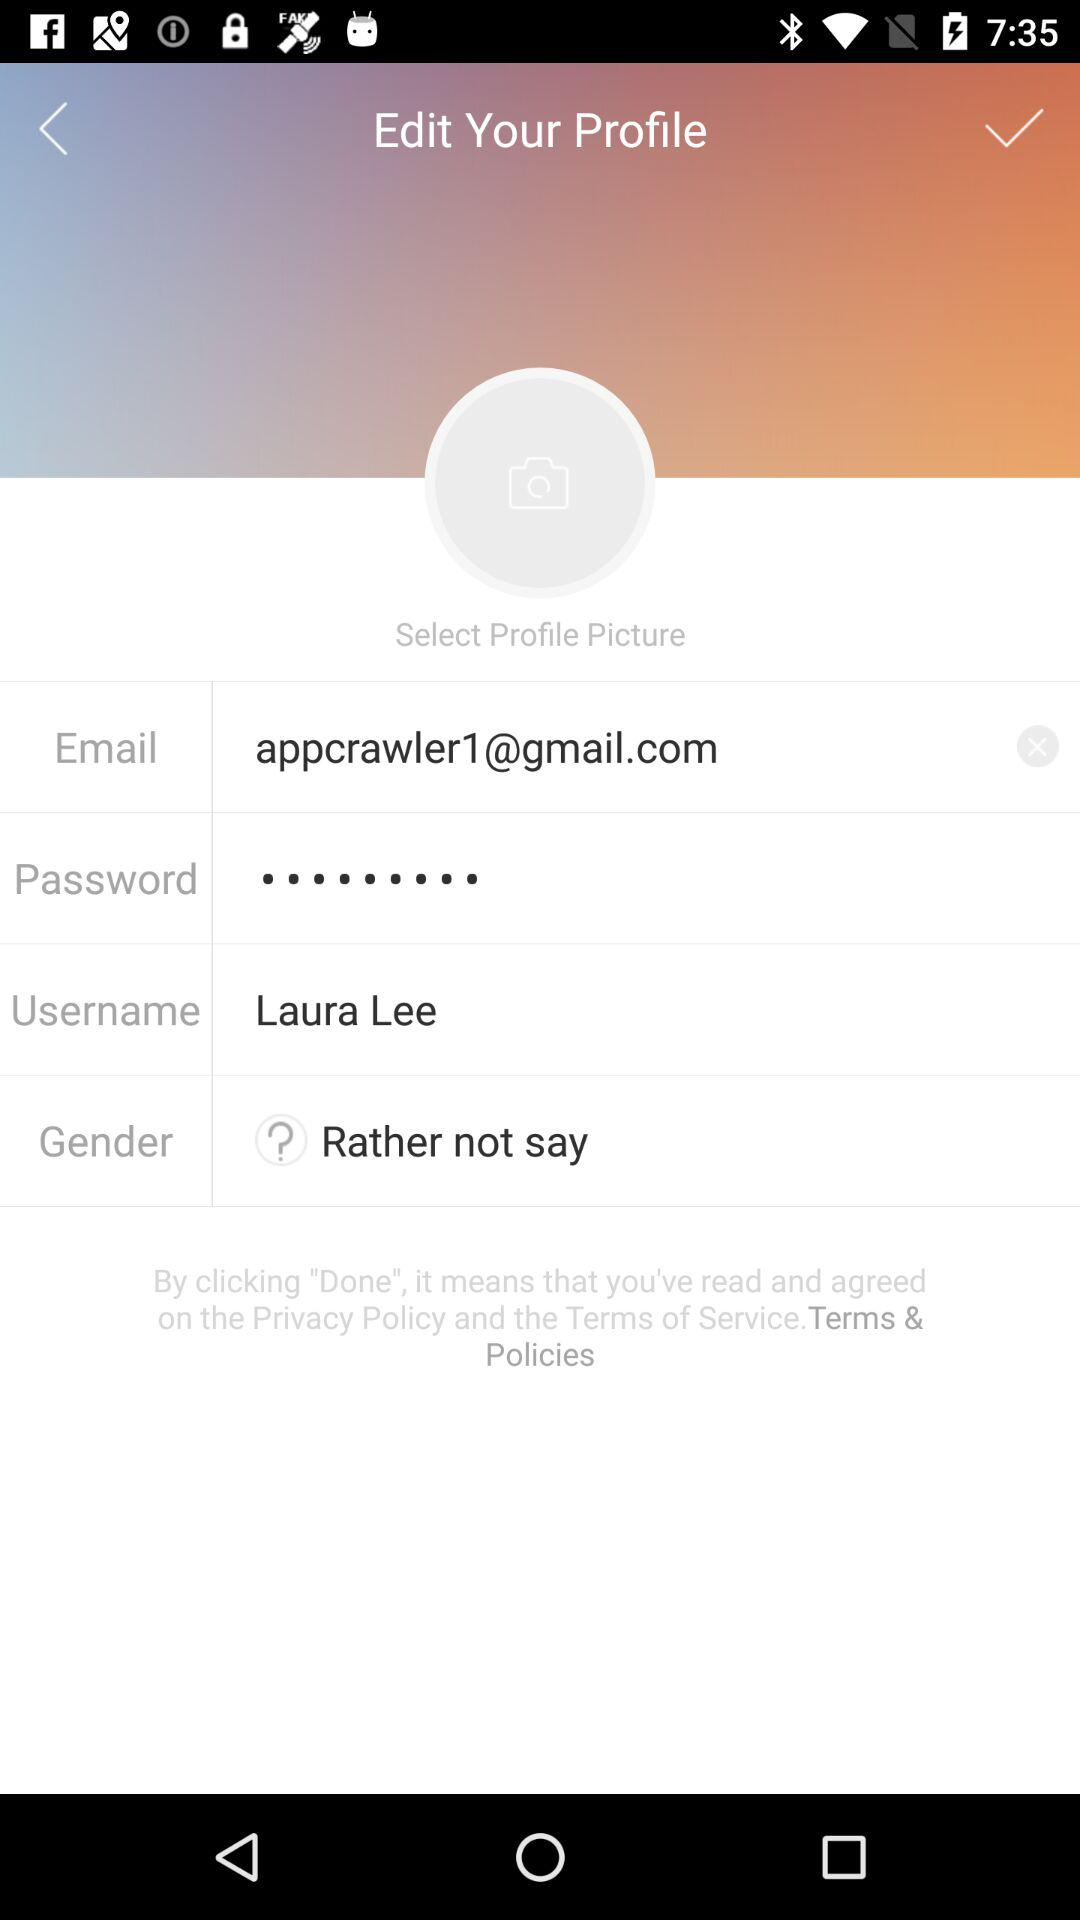What is the username? The username is "Laura Lee". 